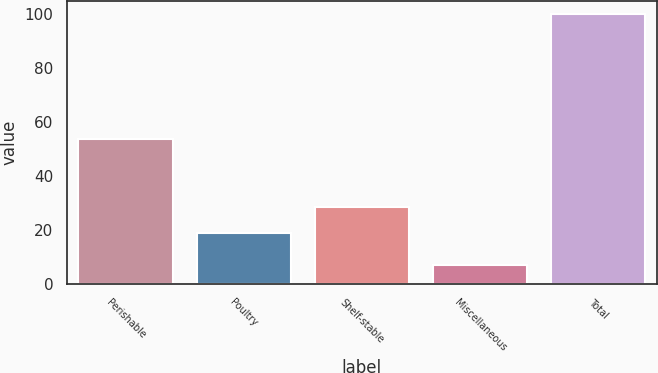Convert chart to OTSL. <chart><loc_0><loc_0><loc_500><loc_500><bar_chart><fcel>Perishable<fcel>Poultry<fcel>Shelf-stable<fcel>Miscellaneous<fcel>Total<nl><fcel>53.7<fcel>19.1<fcel>28.4<fcel>7<fcel>100<nl></chart> 